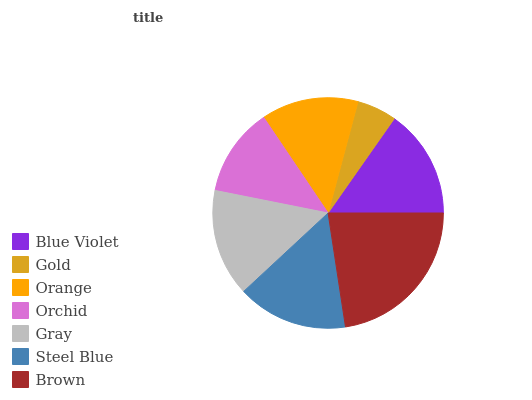Is Gold the minimum?
Answer yes or no. Yes. Is Brown the maximum?
Answer yes or no. Yes. Is Orange the minimum?
Answer yes or no. No. Is Orange the maximum?
Answer yes or no. No. Is Orange greater than Gold?
Answer yes or no. Yes. Is Gold less than Orange?
Answer yes or no. Yes. Is Gold greater than Orange?
Answer yes or no. No. Is Orange less than Gold?
Answer yes or no. No. Is Gray the high median?
Answer yes or no. Yes. Is Gray the low median?
Answer yes or no. Yes. Is Blue Violet the high median?
Answer yes or no. No. Is Steel Blue the low median?
Answer yes or no. No. 